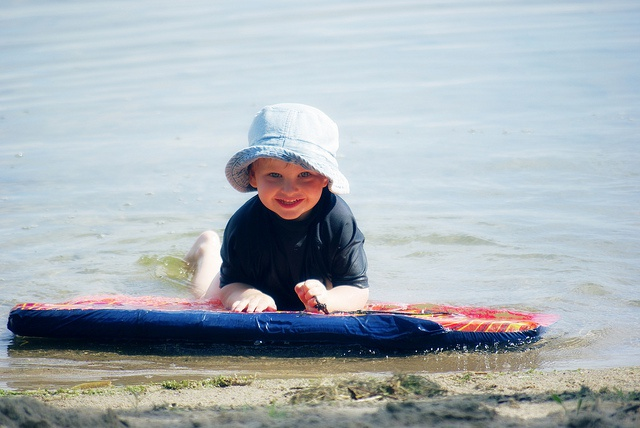Describe the objects in this image and their specific colors. I can see people in lightblue, black, white, brown, and gray tones and surfboard in lightblue, black, navy, blue, and lightgray tones in this image. 